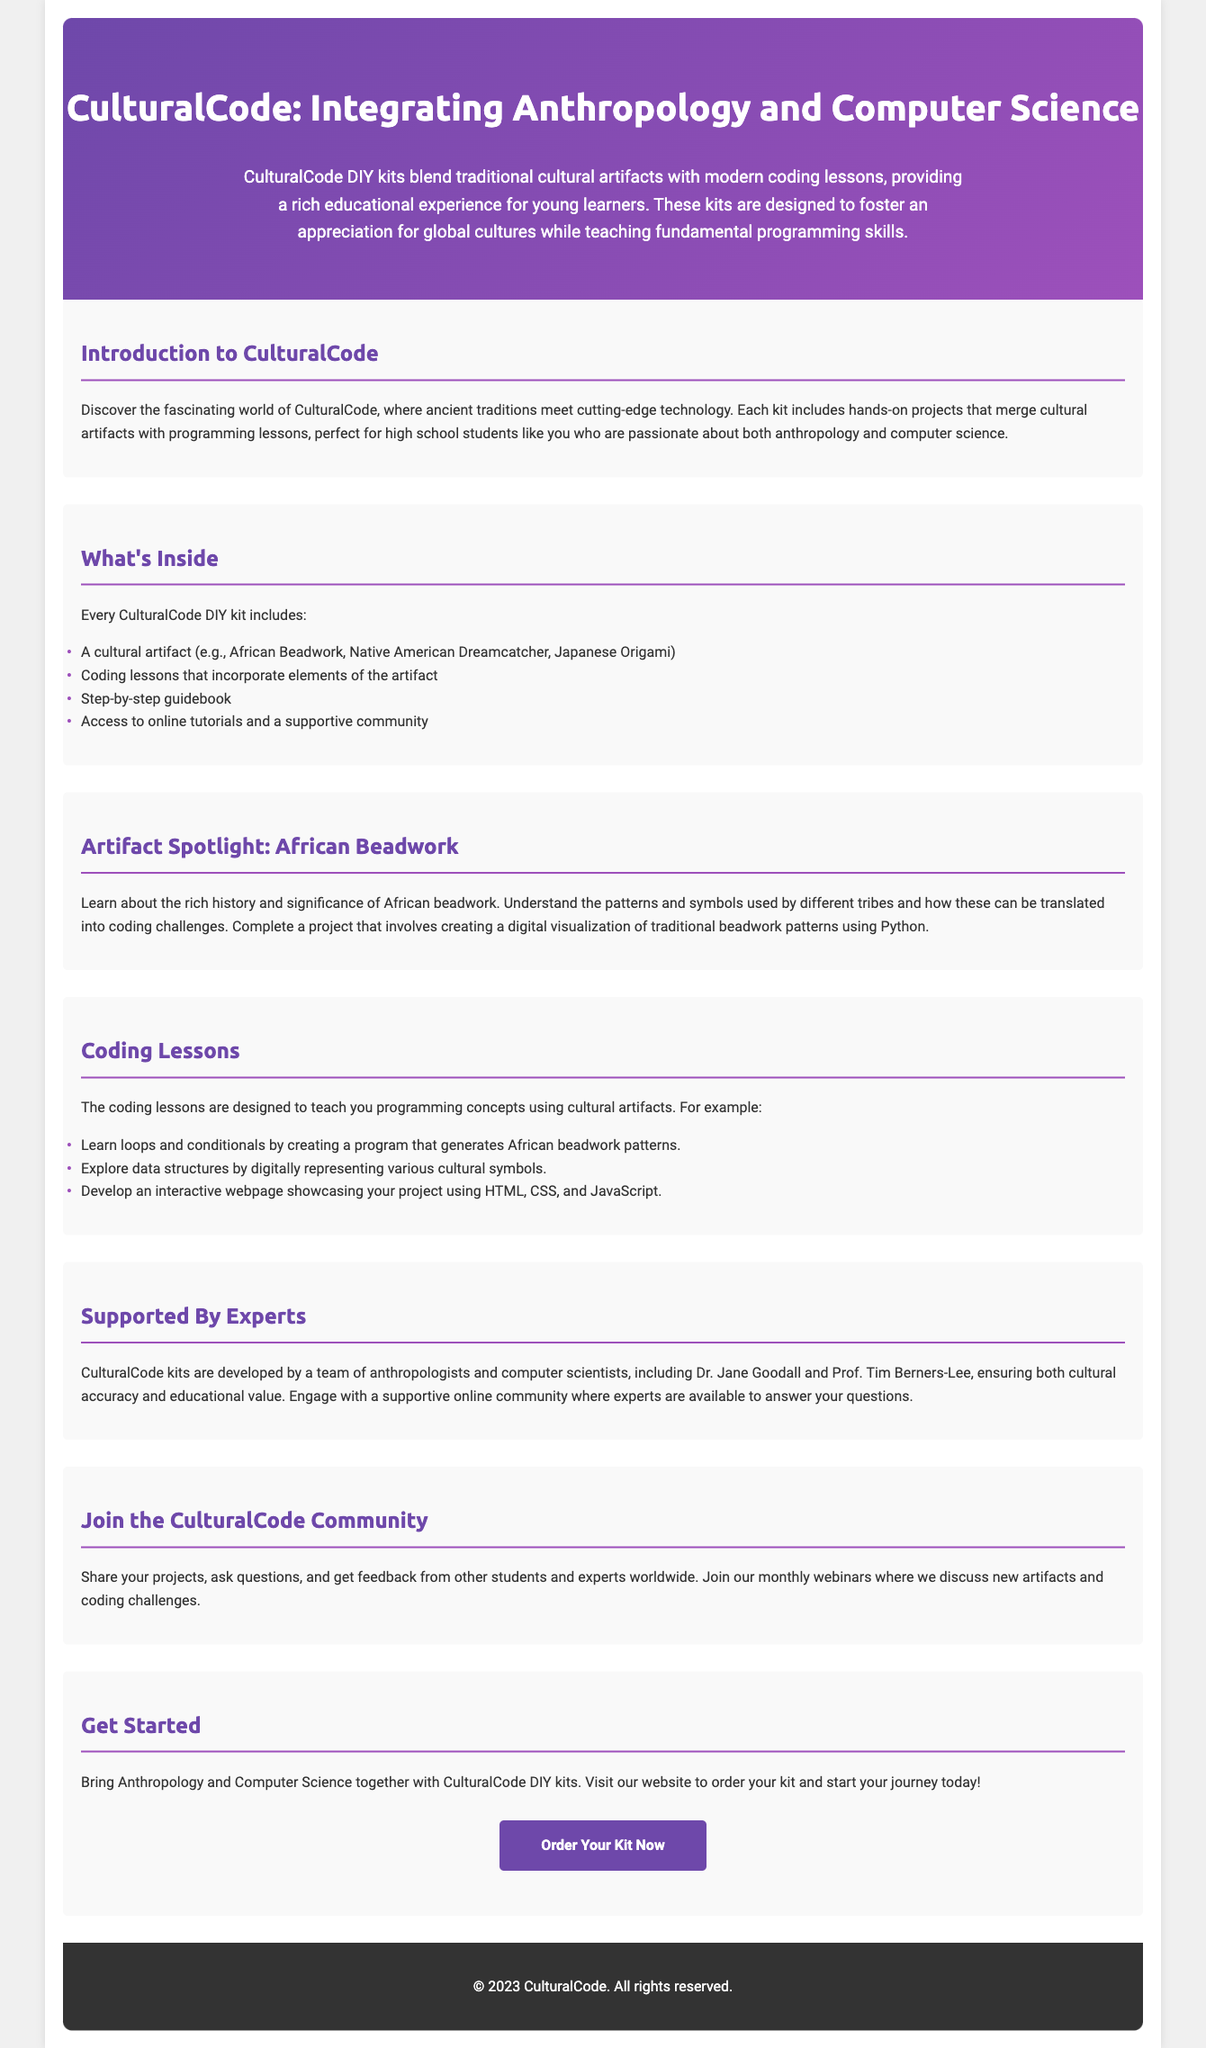What are CulturalCode DIY kits? CulturalCode DIY kits blend traditional cultural artifacts with modern coding lessons, providing a rich educational experience for young learners.
Answer: Educational kits Who are the experts developing the CulturalCode kits? The kits are developed by a team of anthropologists and computer scientists, including Dr. Jane Goodall and Prof. Tim Berners-Lee.
Answer: Dr. Jane Goodall and Prof. Tim Berners-Lee What is an example of a cultural artifact included in the kits? Each kit includes a cultural artifact, which can be African Beadwork, Native American Dreamcatcher, or Japanese Origami.
Answer: African Beadwork What programming language is used for the digital visualization project? The document states that participants complete a project using Python to create a visualization of traditional beadwork patterns.
Answer: Python What is a key programming concept taught through the beadwork project? A key concept is loops and conditionals, which students learn by creating a program that generates patterns.
Answer: Loops and conditionals What type of support can students expect from the CulturalCode community? Students can engage with a supportive online community where experts are available to answer their questions.
Answer: Expert support What is the call to action presented at the end of the document? The call to action encourages readers to visit the website to order their kit and start their journey.
Answer: Order Your Kit Now 